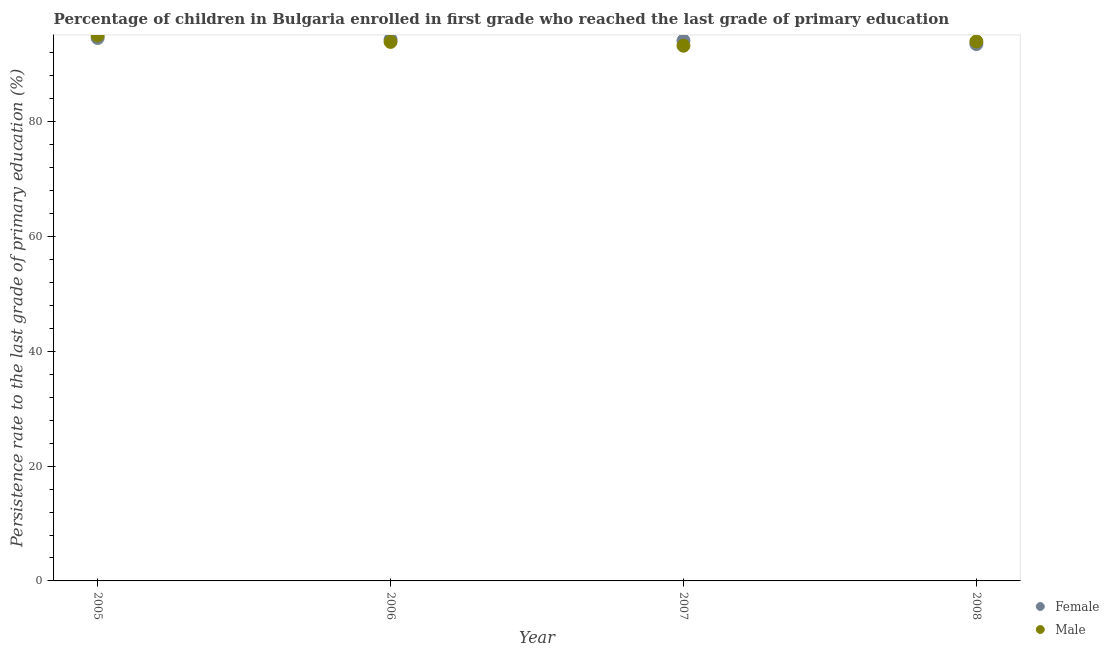How many different coloured dotlines are there?
Your answer should be compact. 2. Is the number of dotlines equal to the number of legend labels?
Keep it short and to the point. Yes. What is the persistence rate of male students in 2008?
Ensure brevity in your answer.  94. Across all years, what is the maximum persistence rate of male students?
Your answer should be very brief. 95.06. Across all years, what is the minimum persistence rate of male students?
Provide a short and direct response. 93.26. In which year was the persistence rate of male students maximum?
Your answer should be compact. 2005. What is the total persistence rate of female students in the graph?
Provide a succinct answer. 376.65. What is the difference between the persistence rate of male students in 2006 and that in 2008?
Provide a short and direct response. -0.08. What is the difference between the persistence rate of male students in 2006 and the persistence rate of female students in 2008?
Ensure brevity in your answer.  0.37. What is the average persistence rate of male students per year?
Offer a very short reply. 94.06. In the year 2006, what is the difference between the persistence rate of male students and persistence rate of female students?
Ensure brevity in your answer.  -0.42. What is the ratio of the persistence rate of male students in 2005 to that in 2007?
Keep it short and to the point. 1.02. Is the persistence rate of female students in 2007 less than that in 2008?
Offer a terse response. No. What is the difference between the highest and the second highest persistence rate of female students?
Offer a terse response. 0.26. What is the difference between the highest and the lowest persistence rate of male students?
Make the answer very short. 1.8. In how many years, is the persistence rate of male students greater than the average persistence rate of male students taken over all years?
Ensure brevity in your answer.  1. Does the persistence rate of male students monotonically increase over the years?
Make the answer very short. No. What is the difference between two consecutive major ticks on the Y-axis?
Your answer should be compact. 20. What is the title of the graph?
Provide a succinct answer. Percentage of children in Bulgaria enrolled in first grade who reached the last grade of primary education. Does "From production" appear as one of the legend labels in the graph?
Your answer should be very brief. No. What is the label or title of the Y-axis?
Make the answer very short. Persistence rate to the last grade of primary education (%). What is the Persistence rate to the last grade of primary education (%) in Female in 2005?
Give a very brief answer. 94.61. What is the Persistence rate to the last grade of primary education (%) in Male in 2005?
Give a very brief answer. 95.06. What is the Persistence rate to the last grade of primary education (%) in Female in 2006?
Offer a very short reply. 94.35. What is the Persistence rate to the last grade of primary education (%) of Male in 2006?
Ensure brevity in your answer.  93.92. What is the Persistence rate to the last grade of primary education (%) of Female in 2007?
Offer a very short reply. 94.15. What is the Persistence rate to the last grade of primary education (%) of Male in 2007?
Offer a very short reply. 93.26. What is the Persistence rate to the last grade of primary education (%) of Female in 2008?
Offer a terse response. 93.55. What is the Persistence rate to the last grade of primary education (%) of Male in 2008?
Keep it short and to the point. 94. Across all years, what is the maximum Persistence rate to the last grade of primary education (%) of Female?
Ensure brevity in your answer.  94.61. Across all years, what is the maximum Persistence rate to the last grade of primary education (%) in Male?
Give a very brief answer. 95.06. Across all years, what is the minimum Persistence rate to the last grade of primary education (%) of Female?
Ensure brevity in your answer.  93.55. Across all years, what is the minimum Persistence rate to the last grade of primary education (%) of Male?
Keep it short and to the point. 93.26. What is the total Persistence rate to the last grade of primary education (%) in Female in the graph?
Your answer should be very brief. 376.64. What is the total Persistence rate to the last grade of primary education (%) of Male in the graph?
Provide a succinct answer. 376.24. What is the difference between the Persistence rate to the last grade of primary education (%) in Female in 2005 and that in 2006?
Your answer should be compact. 0.26. What is the difference between the Persistence rate to the last grade of primary education (%) in Male in 2005 and that in 2006?
Offer a very short reply. 1.14. What is the difference between the Persistence rate to the last grade of primary education (%) in Female in 2005 and that in 2007?
Offer a very short reply. 0.46. What is the difference between the Persistence rate to the last grade of primary education (%) in Male in 2005 and that in 2007?
Offer a terse response. 1.8. What is the difference between the Persistence rate to the last grade of primary education (%) in Female in 2005 and that in 2008?
Your answer should be compact. 1.06. What is the difference between the Persistence rate to the last grade of primary education (%) in Male in 2005 and that in 2008?
Provide a short and direct response. 1.06. What is the difference between the Persistence rate to the last grade of primary education (%) in Female in 2006 and that in 2007?
Make the answer very short. 0.2. What is the difference between the Persistence rate to the last grade of primary education (%) of Male in 2006 and that in 2007?
Offer a terse response. 0.66. What is the difference between the Persistence rate to the last grade of primary education (%) of Female in 2006 and that in 2008?
Offer a terse response. 0.8. What is the difference between the Persistence rate to the last grade of primary education (%) in Male in 2006 and that in 2008?
Your answer should be compact. -0.08. What is the difference between the Persistence rate to the last grade of primary education (%) of Female in 2007 and that in 2008?
Your response must be concise. 0.6. What is the difference between the Persistence rate to the last grade of primary education (%) in Male in 2007 and that in 2008?
Provide a succinct answer. -0.74. What is the difference between the Persistence rate to the last grade of primary education (%) in Female in 2005 and the Persistence rate to the last grade of primary education (%) in Male in 2006?
Keep it short and to the point. 0.69. What is the difference between the Persistence rate to the last grade of primary education (%) in Female in 2005 and the Persistence rate to the last grade of primary education (%) in Male in 2007?
Ensure brevity in your answer.  1.35. What is the difference between the Persistence rate to the last grade of primary education (%) in Female in 2005 and the Persistence rate to the last grade of primary education (%) in Male in 2008?
Offer a very short reply. 0.61. What is the difference between the Persistence rate to the last grade of primary education (%) in Female in 2006 and the Persistence rate to the last grade of primary education (%) in Male in 2007?
Provide a short and direct response. 1.09. What is the difference between the Persistence rate to the last grade of primary education (%) in Female in 2006 and the Persistence rate to the last grade of primary education (%) in Male in 2008?
Ensure brevity in your answer.  0.35. What is the difference between the Persistence rate to the last grade of primary education (%) in Female in 2007 and the Persistence rate to the last grade of primary education (%) in Male in 2008?
Offer a very short reply. 0.15. What is the average Persistence rate to the last grade of primary education (%) in Female per year?
Make the answer very short. 94.16. What is the average Persistence rate to the last grade of primary education (%) of Male per year?
Provide a succinct answer. 94.06. In the year 2005, what is the difference between the Persistence rate to the last grade of primary education (%) in Female and Persistence rate to the last grade of primary education (%) in Male?
Offer a terse response. -0.45. In the year 2006, what is the difference between the Persistence rate to the last grade of primary education (%) in Female and Persistence rate to the last grade of primary education (%) in Male?
Keep it short and to the point. 0.42. In the year 2007, what is the difference between the Persistence rate to the last grade of primary education (%) of Female and Persistence rate to the last grade of primary education (%) of Male?
Provide a succinct answer. 0.89. In the year 2008, what is the difference between the Persistence rate to the last grade of primary education (%) in Female and Persistence rate to the last grade of primary education (%) in Male?
Provide a short and direct response. -0.45. What is the ratio of the Persistence rate to the last grade of primary education (%) in Female in 2005 to that in 2006?
Your response must be concise. 1. What is the ratio of the Persistence rate to the last grade of primary education (%) of Male in 2005 to that in 2006?
Provide a short and direct response. 1.01. What is the ratio of the Persistence rate to the last grade of primary education (%) in Male in 2005 to that in 2007?
Your response must be concise. 1.02. What is the ratio of the Persistence rate to the last grade of primary education (%) of Female in 2005 to that in 2008?
Your answer should be compact. 1.01. What is the ratio of the Persistence rate to the last grade of primary education (%) of Male in 2005 to that in 2008?
Make the answer very short. 1.01. What is the ratio of the Persistence rate to the last grade of primary education (%) of Female in 2006 to that in 2007?
Offer a terse response. 1. What is the ratio of the Persistence rate to the last grade of primary education (%) of Male in 2006 to that in 2007?
Give a very brief answer. 1.01. What is the ratio of the Persistence rate to the last grade of primary education (%) in Female in 2006 to that in 2008?
Provide a succinct answer. 1.01. What is the ratio of the Persistence rate to the last grade of primary education (%) in Male in 2006 to that in 2008?
Provide a short and direct response. 1. What is the ratio of the Persistence rate to the last grade of primary education (%) of Female in 2007 to that in 2008?
Give a very brief answer. 1.01. What is the difference between the highest and the second highest Persistence rate to the last grade of primary education (%) in Female?
Ensure brevity in your answer.  0.26. What is the difference between the highest and the second highest Persistence rate to the last grade of primary education (%) in Male?
Give a very brief answer. 1.06. What is the difference between the highest and the lowest Persistence rate to the last grade of primary education (%) of Female?
Keep it short and to the point. 1.06. What is the difference between the highest and the lowest Persistence rate to the last grade of primary education (%) of Male?
Offer a terse response. 1.8. 